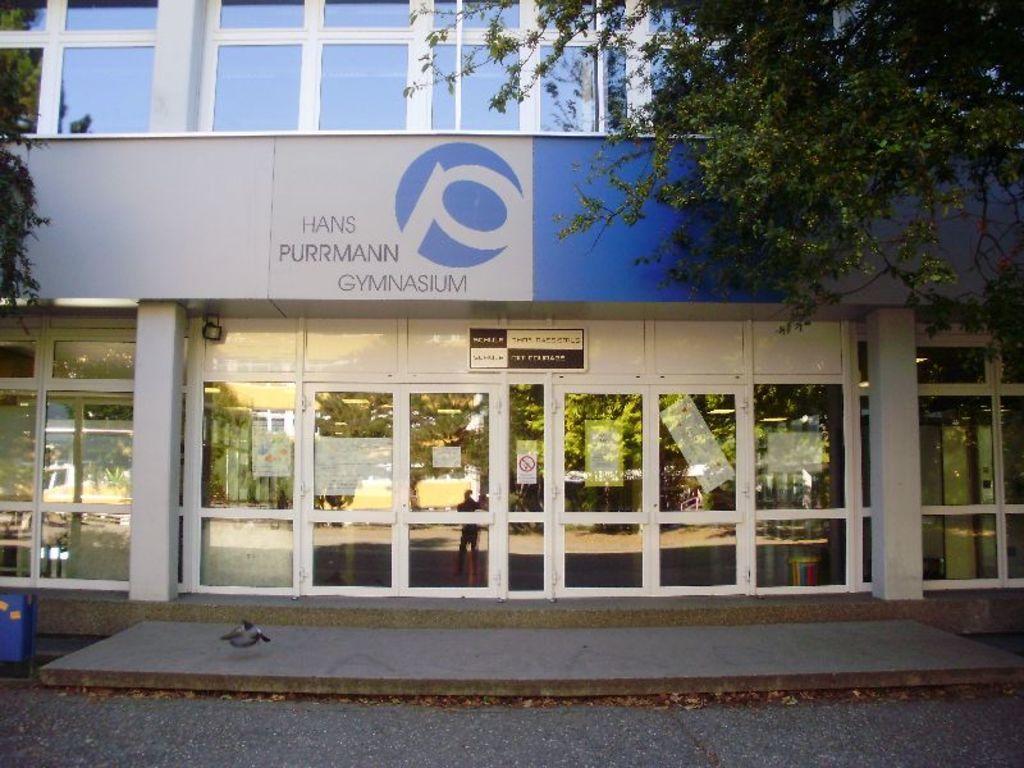Please provide a concise description of this image. This image is clicked on the road. Beside the road there is a building. There are glass walls to the building. There is a board with text on the building. At the top there are leaves of a trees. In the bottom left there is a dustbin on the ground. 